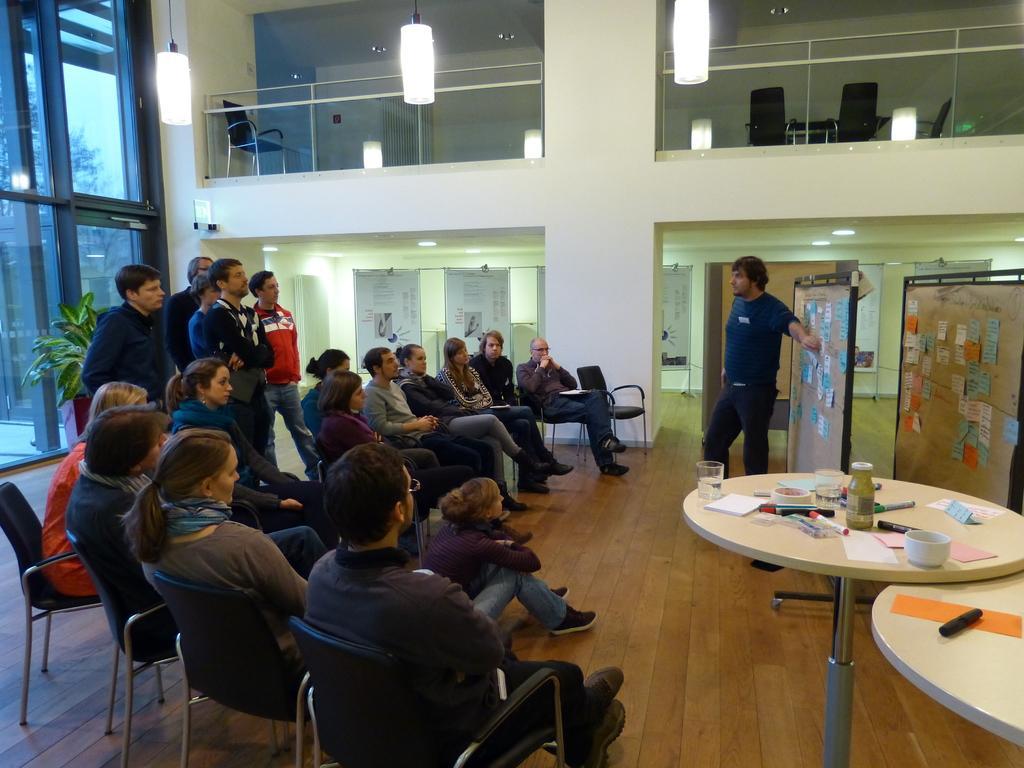Please provide a concise description of this image. The image is taken inside a building. On the left there are many people sitting on the chair. On the right there are boards and there is a man who is explaining something which is written on the board. We can also see tables and there are glasses, cup, papers, pen a bottle a marker and a tape which is placed on the table. On the top there are lights. There is a chair which is on the upstairs. In the background we can also see some boards. 